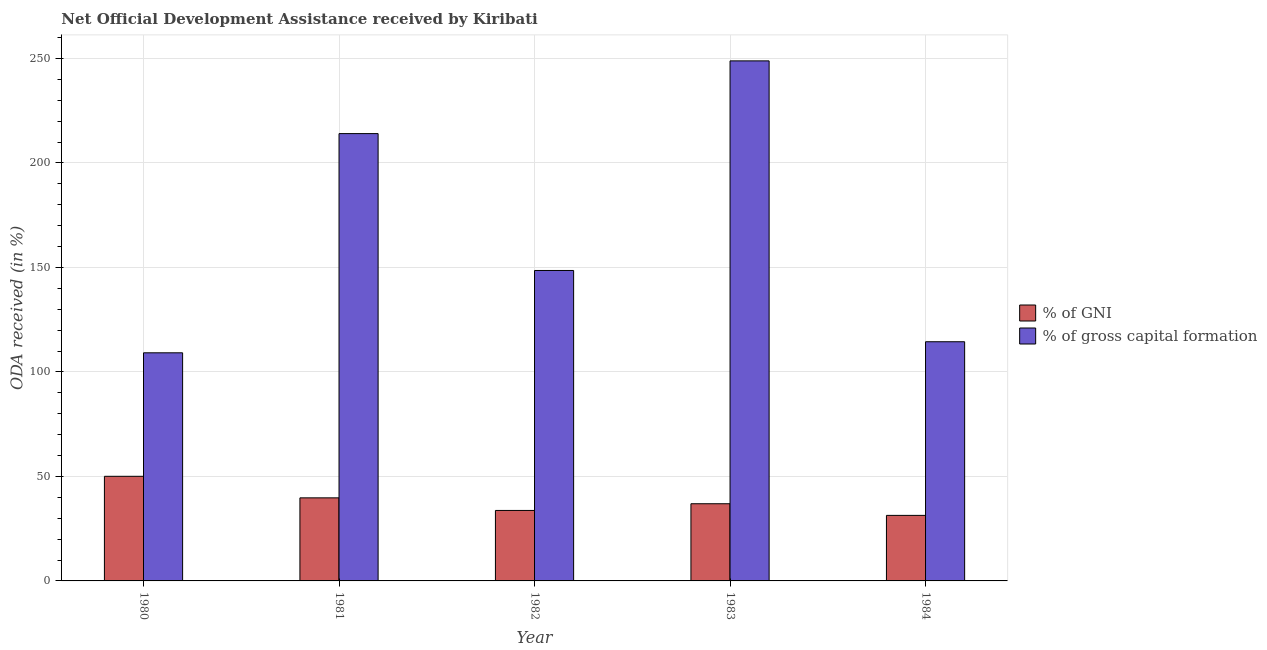Are the number of bars on each tick of the X-axis equal?
Make the answer very short. Yes. How many bars are there on the 2nd tick from the left?
Ensure brevity in your answer.  2. How many bars are there on the 3rd tick from the right?
Ensure brevity in your answer.  2. What is the label of the 4th group of bars from the left?
Ensure brevity in your answer.  1983. In how many cases, is the number of bars for a given year not equal to the number of legend labels?
Ensure brevity in your answer.  0. What is the oda received as percentage of gross capital formation in 1983?
Make the answer very short. 248.84. Across all years, what is the maximum oda received as percentage of gni?
Provide a succinct answer. 50.06. Across all years, what is the minimum oda received as percentage of gross capital formation?
Give a very brief answer. 109.15. What is the total oda received as percentage of gni in the graph?
Provide a short and direct response. 191.82. What is the difference between the oda received as percentage of gni in 1980 and that in 1984?
Your answer should be very brief. 18.7. What is the difference between the oda received as percentage of gross capital formation in 1984 and the oda received as percentage of gni in 1983?
Offer a terse response. -134.39. What is the average oda received as percentage of gni per year?
Your answer should be compact. 38.36. In the year 1982, what is the difference between the oda received as percentage of gross capital formation and oda received as percentage of gni?
Your response must be concise. 0. In how many years, is the oda received as percentage of gni greater than 50 %?
Keep it short and to the point. 1. What is the ratio of the oda received as percentage of gni in 1980 to that in 1984?
Ensure brevity in your answer.  1.6. Is the oda received as percentage of gross capital formation in 1981 less than that in 1984?
Give a very brief answer. No. Is the difference between the oda received as percentage of gni in 1980 and 1981 greater than the difference between the oda received as percentage of gross capital formation in 1980 and 1981?
Make the answer very short. No. What is the difference between the highest and the second highest oda received as percentage of gni?
Your answer should be compact. 10.31. What is the difference between the highest and the lowest oda received as percentage of gni?
Your response must be concise. 18.7. Is the sum of the oda received as percentage of gross capital formation in 1983 and 1984 greater than the maximum oda received as percentage of gni across all years?
Offer a very short reply. Yes. What does the 2nd bar from the left in 1984 represents?
Offer a terse response. % of gross capital formation. What does the 2nd bar from the right in 1983 represents?
Give a very brief answer. % of GNI. Are the values on the major ticks of Y-axis written in scientific E-notation?
Your answer should be compact. No. Where does the legend appear in the graph?
Keep it short and to the point. Center right. How are the legend labels stacked?
Provide a succinct answer. Vertical. What is the title of the graph?
Provide a short and direct response. Net Official Development Assistance received by Kiribati. What is the label or title of the X-axis?
Provide a short and direct response. Year. What is the label or title of the Y-axis?
Offer a terse response. ODA received (in %). What is the ODA received (in %) of % of GNI in 1980?
Keep it short and to the point. 50.06. What is the ODA received (in %) of % of gross capital formation in 1980?
Your answer should be very brief. 109.15. What is the ODA received (in %) in % of GNI in 1981?
Make the answer very short. 39.75. What is the ODA received (in %) of % of gross capital formation in 1981?
Your answer should be very brief. 214.04. What is the ODA received (in %) in % of GNI in 1982?
Offer a terse response. 33.72. What is the ODA received (in %) in % of gross capital formation in 1982?
Offer a terse response. 148.55. What is the ODA received (in %) in % of GNI in 1983?
Provide a short and direct response. 36.93. What is the ODA received (in %) of % of gross capital formation in 1983?
Make the answer very short. 248.84. What is the ODA received (in %) of % of GNI in 1984?
Keep it short and to the point. 31.36. What is the ODA received (in %) of % of gross capital formation in 1984?
Provide a succinct answer. 114.45. Across all years, what is the maximum ODA received (in %) of % of GNI?
Make the answer very short. 50.06. Across all years, what is the maximum ODA received (in %) in % of gross capital formation?
Your answer should be very brief. 248.84. Across all years, what is the minimum ODA received (in %) of % of GNI?
Ensure brevity in your answer.  31.36. Across all years, what is the minimum ODA received (in %) of % of gross capital formation?
Your answer should be compact. 109.15. What is the total ODA received (in %) of % of GNI in the graph?
Keep it short and to the point. 191.82. What is the total ODA received (in %) in % of gross capital formation in the graph?
Offer a very short reply. 835.03. What is the difference between the ODA received (in %) of % of GNI in 1980 and that in 1981?
Give a very brief answer. 10.31. What is the difference between the ODA received (in %) in % of gross capital formation in 1980 and that in 1981?
Provide a short and direct response. -104.89. What is the difference between the ODA received (in %) of % of GNI in 1980 and that in 1982?
Offer a terse response. 16.34. What is the difference between the ODA received (in %) in % of gross capital formation in 1980 and that in 1982?
Offer a terse response. -39.4. What is the difference between the ODA received (in %) in % of GNI in 1980 and that in 1983?
Make the answer very short. 13.12. What is the difference between the ODA received (in %) in % of gross capital formation in 1980 and that in 1983?
Provide a succinct answer. -139.69. What is the difference between the ODA received (in %) in % of GNI in 1980 and that in 1984?
Ensure brevity in your answer.  18.7. What is the difference between the ODA received (in %) of % of gross capital formation in 1980 and that in 1984?
Your answer should be compact. -5.3. What is the difference between the ODA received (in %) in % of GNI in 1981 and that in 1982?
Provide a short and direct response. 6.02. What is the difference between the ODA received (in %) in % of gross capital formation in 1981 and that in 1982?
Provide a succinct answer. 65.5. What is the difference between the ODA received (in %) in % of GNI in 1981 and that in 1983?
Your answer should be very brief. 2.81. What is the difference between the ODA received (in %) of % of gross capital formation in 1981 and that in 1983?
Make the answer very short. -34.8. What is the difference between the ODA received (in %) of % of GNI in 1981 and that in 1984?
Give a very brief answer. 8.39. What is the difference between the ODA received (in %) of % of gross capital formation in 1981 and that in 1984?
Provide a short and direct response. 99.59. What is the difference between the ODA received (in %) in % of GNI in 1982 and that in 1983?
Give a very brief answer. -3.21. What is the difference between the ODA received (in %) in % of gross capital formation in 1982 and that in 1983?
Your answer should be very brief. -100.29. What is the difference between the ODA received (in %) in % of GNI in 1982 and that in 1984?
Offer a very short reply. 2.37. What is the difference between the ODA received (in %) in % of gross capital formation in 1982 and that in 1984?
Ensure brevity in your answer.  34.1. What is the difference between the ODA received (in %) of % of GNI in 1983 and that in 1984?
Keep it short and to the point. 5.58. What is the difference between the ODA received (in %) of % of gross capital formation in 1983 and that in 1984?
Keep it short and to the point. 134.39. What is the difference between the ODA received (in %) in % of GNI in 1980 and the ODA received (in %) in % of gross capital formation in 1981?
Your answer should be very brief. -163.98. What is the difference between the ODA received (in %) in % of GNI in 1980 and the ODA received (in %) in % of gross capital formation in 1982?
Provide a short and direct response. -98.49. What is the difference between the ODA received (in %) in % of GNI in 1980 and the ODA received (in %) in % of gross capital formation in 1983?
Make the answer very short. -198.78. What is the difference between the ODA received (in %) of % of GNI in 1980 and the ODA received (in %) of % of gross capital formation in 1984?
Keep it short and to the point. -64.39. What is the difference between the ODA received (in %) of % of GNI in 1981 and the ODA received (in %) of % of gross capital formation in 1982?
Offer a terse response. -108.8. What is the difference between the ODA received (in %) of % of GNI in 1981 and the ODA received (in %) of % of gross capital formation in 1983?
Make the answer very short. -209.1. What is the difference between the ODA received (in %) in % of GNI in 1981 and the ODA received (in %) in % of gross capital formation in 1984?
Ensure brevity in your answer.  -74.7. What is the difference between the ODA received (in %) of % of GNI in 1982 and the ODA received (in %) of % of gross capital formation in 1983?
Provide a short and direct response. -215.12. What is the difference between the ODA received (in %) of % of GNI in 1982 and the ODA received (in %) of % of gross capital formation in 1984?
Provide a succinct answer. -80.73. What is the difference between the ODA received (in %) in % of GNI in 1983 and the ODA received (in %) in % of gross capital formation in 1984?
Your answer should be very brief. -77.51. What is the average ODA received (in %) of % of GNI per year?
Offer a terse response. 38.36. What is the average ODA received (in %) in % of gross capital formation per year?
Keep it short and to the point. 167.01. In the year 1980, what is the difference between the ODA received (in %) in % of GNI and ODA received (in %) in % of gross capital formation?
Your response must be concise. -59.09. In the year 1981, what is the difference between the ODA received (in %) in % of GNI and ODA received (in %) in % of gross capital formation?
Provide a short and direct response. -174.3. In the year 1982, what is the difference between the ODA received (in %) in % of GNI and ODA received (in %) in % of gross capital formation?
Ensure brevity in your answer.  -114.82. In the year 1983, what is the difference between the ODA received (in %) in % of GNI and ODA received (in %) in % of gross capital formation?
Ensure brevity in your answer.  -211.91. In the year 1984, what is the difference between the ODA received (in %) in % of GNI and ODA received (in %) in % of gross capital formation?
Make the answer very short. -83.09. What is the ratio of the ODA received (in %) in % of GNI in 1980 to that in 1981?
Offer a terse response. 1.26. What is the ratio of the ODA received (in %) in % of gross capital formation in 1980 to that in 1981?
Offer a terse response. 0.51. What is the ratio of the ODA received (in %) of % of GNI in 1980 to that in 1982?
Offer a terse response. 1.48. What is the ratio of the ODA received (in %) of % of gross capital formation in 1980 to that in 1982?
Keep it short and to the point. 0.73. What is the ratio of the ODA received (in %) of % of GNI in 1980 to that in 1983?
Give a very brief answer. 1.36. What is the ratio of the ODA received (in %) in % of gross capital formation in 1980 to that in 1983?
Offer a very short reply. 0.44. What is the ratio of the ODA received (in %) in % of GNI in 1980 to that in 1984?
Ensure brevity in your answer.  1.6. What is the ratio of the ODA received (in %) of % of gross capital formation in 1980 to that in 1984?
Provide a succinct answer. 0.95. What is the ratio of the ODA received (in %) of % of GNI in 1981 to that in 1982?
Ensure brevity in your answer.  1.18. What is the ratio of the ODA received (in %) of % of gross capital formation in 1981 to that in 1982?
Your answer should be very brief. 1.44. What is the ratio of the ODA received (in %) in % of GNI in 1981 to that in 1983?
Provide a short and direct response. 1.08. What is the ratio of the ODA received (in %) of % of gross capital formation in 1981 to that in 1983?
Your response must be concise. 0.86. What is the ratio of the ODA received (in %) of % of GNI in 1981 to that in 1984?
Offer a very short reply. 1.27. What is the ratio of the ODA received (in %) in % of gross capital formation in 1981 to that in 1984?
Ensure brevity in your answer.  1.87. What is the ratio of the ODA received (in %) in % of GNI in 1982 to that in 1983?
Ensure brevity in your answer.  0.91. What is the ratio of the ODA received (in %) in % of gross capital formation in 1982 to that in 1983?
Your response must be concise. 0.6. What is the ratio of the ODA received (in %) in % of GNI in 1982 to that in 1984?
Keep it short and to the point. 1.08. What is the ratio of the ODA received (in %) in % of gross capital formation in 1982 to that in 1984?
Ensure brevity in your answer.  1.3. What is the ratio of the ODA received (in %) of % of GNI in 1983 to that in 1984?
Provide a succinct answer. 1.18. What is the ratio of the ODA received (in %) in % of gross capital formation in 1983 to that in 1984?
Give a very brief answer. 2.17. What is the difference between the highest and the second highest ODA received (in %) in % of GNI?
Ensure brevity in your answer.  10.31. What is the difference between the highest and the second highest ODA received (in %) in % of gross capital formation?
Offer a terse response. 34.8. What is the difference between the highest and the lowest ODA received (in %) of % of GNI?
Offer a terse response. 18.7. What is the difference between the highest and the lowest ODA received (in %) in % of gross capital formation?
Provide a short and direct response. 139.69. 